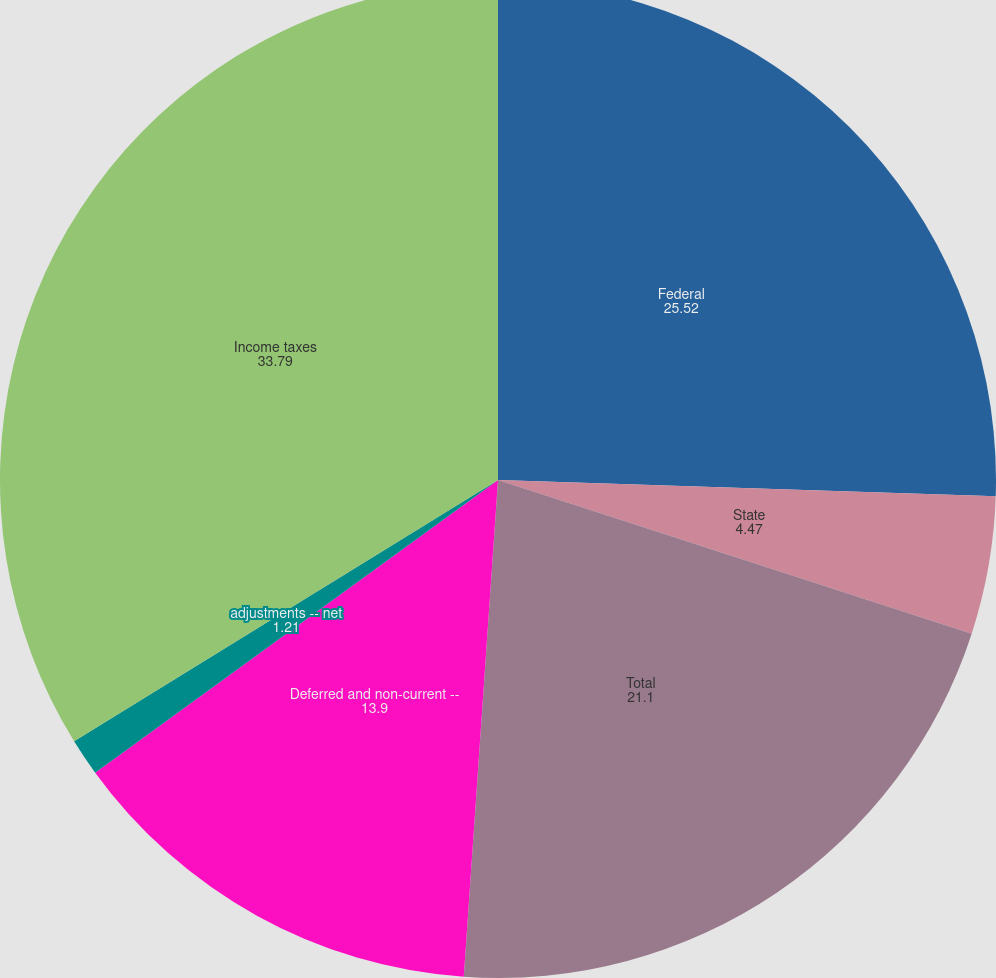Convert chart. <chart><loc_0><loc_0><loc_500><loc_500><pie_chart><fcel>Federal<fcel>State<fcel>Total<fcel>Deferred and non-current --<fcel>adjustments -- net<fcel>Income taxes<nl><fcel>25.52%<fcel>4.47%<fcel>21.1%<fcel>13.9%<fcel>1.21%<fcel>33.79%<nl></chart> 